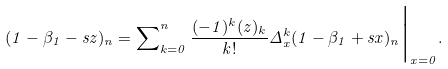Convert formula to latex. <formula><loc_0><loc_0><loc_500><loc_500>( 1 - \beta _ { 1 } - s z ) _ { n } = \sum \nolimits _ { k = 0 } ^ { n } \frac { ( - 1 ) ^ { k } ( z ) _ { k } } { k ! } \Delta _ { x } ^ { k } ( 1 - \beta _ { 1 } + s x ) _ { n } \Big | _ { x = 0 } .</formula> 